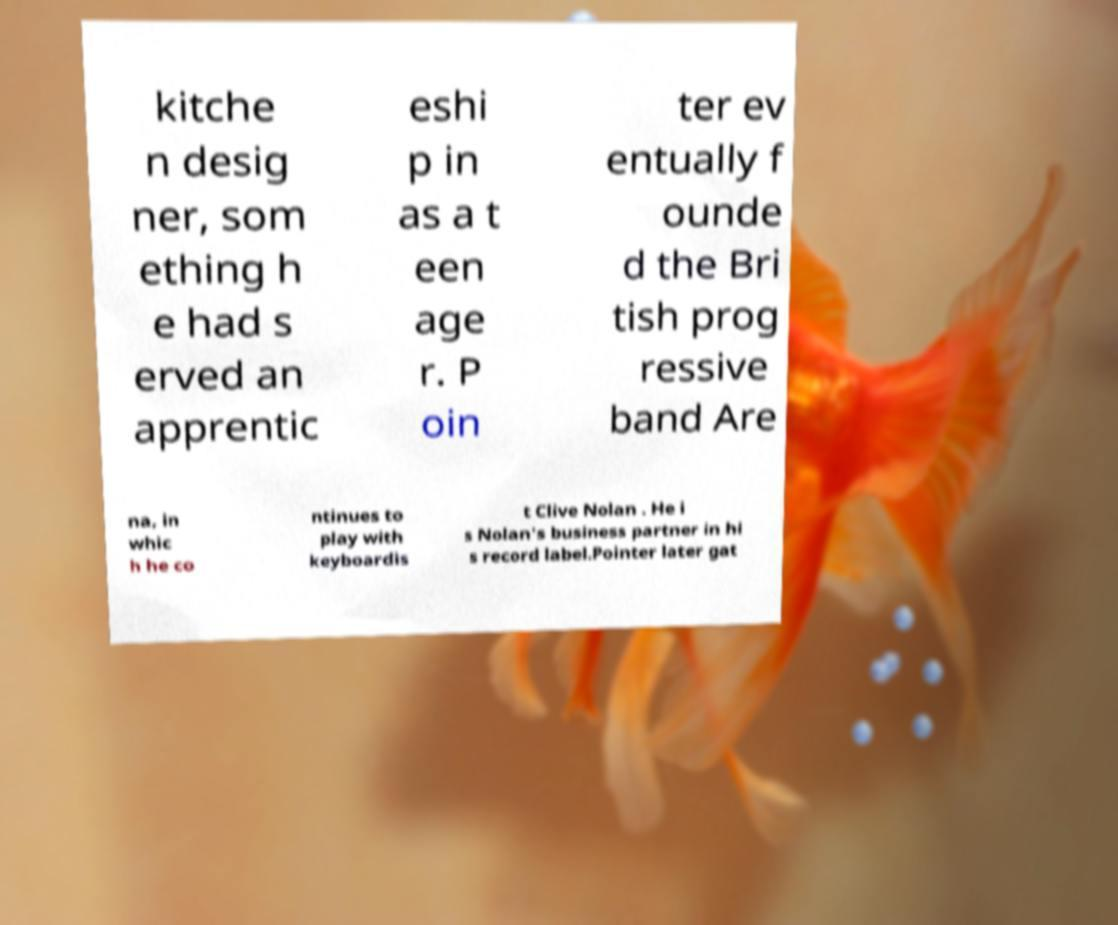Can you read and provide the text displayed in the image?This photo seems to have some interesting text. Can you extract and type it out for me? kitche n desig ner, som ething h e had s erved an apprentic eshi p in as a t een age r. P oin ter ev entually f ounde d the Bri tish prog ressive band Are na, in whic h he co ntinues to play with keyboardis t Clive Nolan . He i s Nolan's business partner in hi s record label.Pointer later gat 